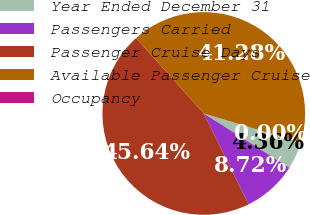<chart> <loc_0><loc_0><loc_500><loc_500><pie_chart><fcel>Year Ended December 31<fcel>Passengers Carried<fcel>Passenger Cruise Days<fcel>Available Passenger Cruise<fcel>Occupancy<nl><fcel>4.36%<fcel>8.72%<fcel>45.64%<fcel>41.28%<fcel>0.0%<nl></chart> 